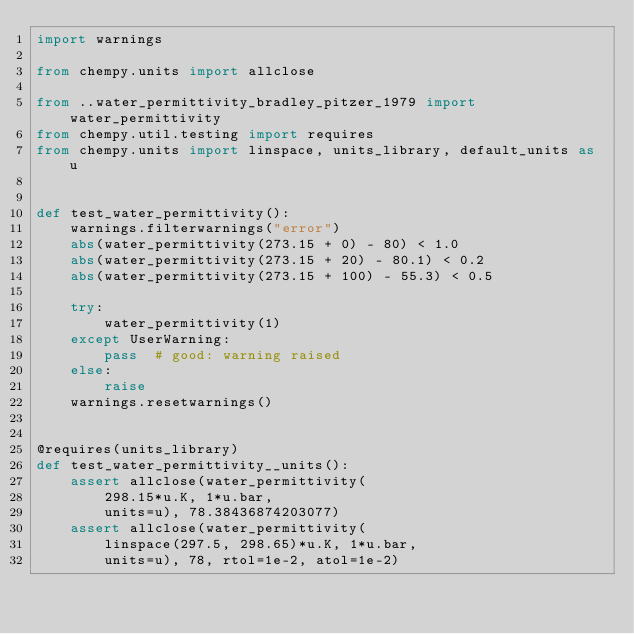Convert code to text. <code><loc_0><loc_0><loc_500><loc_500><_Python_>import warnings

from chempy.units import allclose

from ..water_permittivity_bradley_pitzer_1979 import water_permittivity
from chempy.util.testing import requires
from chempy.units import linspace, units_library, default_units as u


def test_water_permittivity():
    warnings.filterwarnings("error")
    abs(water_permittivity(273.15 + 0) - 80) < 1.0
    abs(water_permittivity(273.15 + 20) - 80.1) < 0.2
    abs(water_permittivity(273.15 + 100) - 55.3) < 0.5

    try:
        water_permittivity(1)
    except UserWarning:
        pass  # good: warning raised
    else:
        raise
    warnings.resetwarnings()


@requires(units_library)
def test_water_permittivity__units():
    assert allclose(water_permittivity(
        298.15*u.K, 1*u.bar,
        units=u), 78.38436874203077)
    assert allclose(water_permittivity(
        linspace(297.5, 298.65)*u.K, 1*u.bar,
        units=u), 78, rtol=1e-2, atol=1e-2)
</code> 